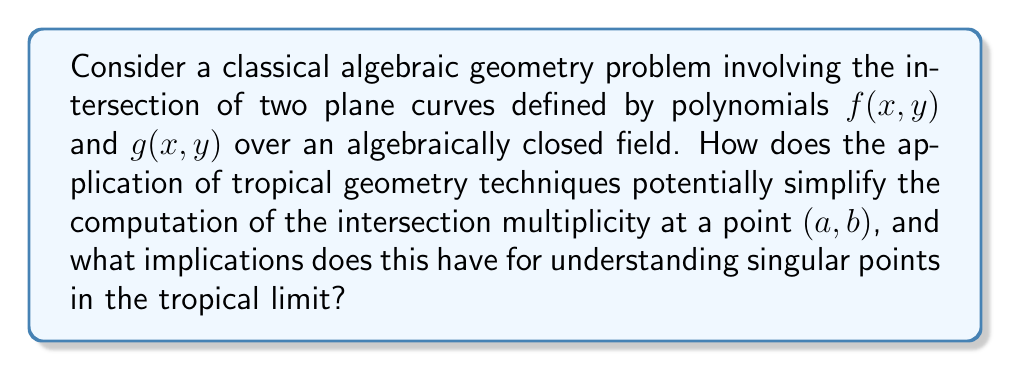What is the answer to this math problem? 1. In classical algebraic geometry, computing the intersection multiplicity of two plane curves at a point $(a,b)$ involves:
   a) Translating the curves to the origin
   b) Computing the dimension of the local ring $\mathcal{O}_{(a,b)}/(f,g)$ as a vector space

2. Tropical geometry introduces the concept of tropicalization:
   $$\text{trop}(f) = \text{conv}\{(i,j) \in \mathbb{Z}^2 : c_{ij} \neq 0\}$$
   where $f(x,y) = \sum c_{ij}x^iy^j$

3. The tropical limit corresponds to considering the behavior of the curves as the coefficients approach zero or infinity in a controlled manner.

4. In the tropical setting, intersection multiplicities can be computed using the mixed volume of Newton polytopes:
   $$\text{MV}(\text{trop}(f), \text{trop}(g))$$

5. This tropical computation is often simpler and more combinatorial in nature compared to the classical approach.

6. The tropical intersection multiplicity provides an upper bound for the classical multiplicity:
   $$\text{int}_\text{trop}(f,g) \geq \text{int}_\text{classical}(f,g)$$

7. Equality holds in "sufficiently generic" cases, which can be precisely characterized using tropical techniques.

8. For singular points:
   a) Classical approach: Requires complex local analysis
   b) Tropical approach: Singularities correspond to non-transverse intersections of tropical curves

9. Implications for understanding singular points:
   a) Provides a combinatorial classification of singularity types
   b) Allows for easier computation of invariants like delta-invariant
   c) Gives insight into the structure of the moduli space of curves

10. This tropical approach enables:
    a) More efficient algorithms for intersection computations
    b) Better understanding of the behavior of algebraic curves under degeneration
    c) New connections between algebraic geometry and combinatorics
Answer: Tropical geometry simplifies intersection multiplicity computations through mixed volume calculations of Newton polytopes, providing upper bounds for classical multiplicities and offering combinatorial insights into singularities, thus enhancing our understanding of curve degenerations and moduli spaces. 